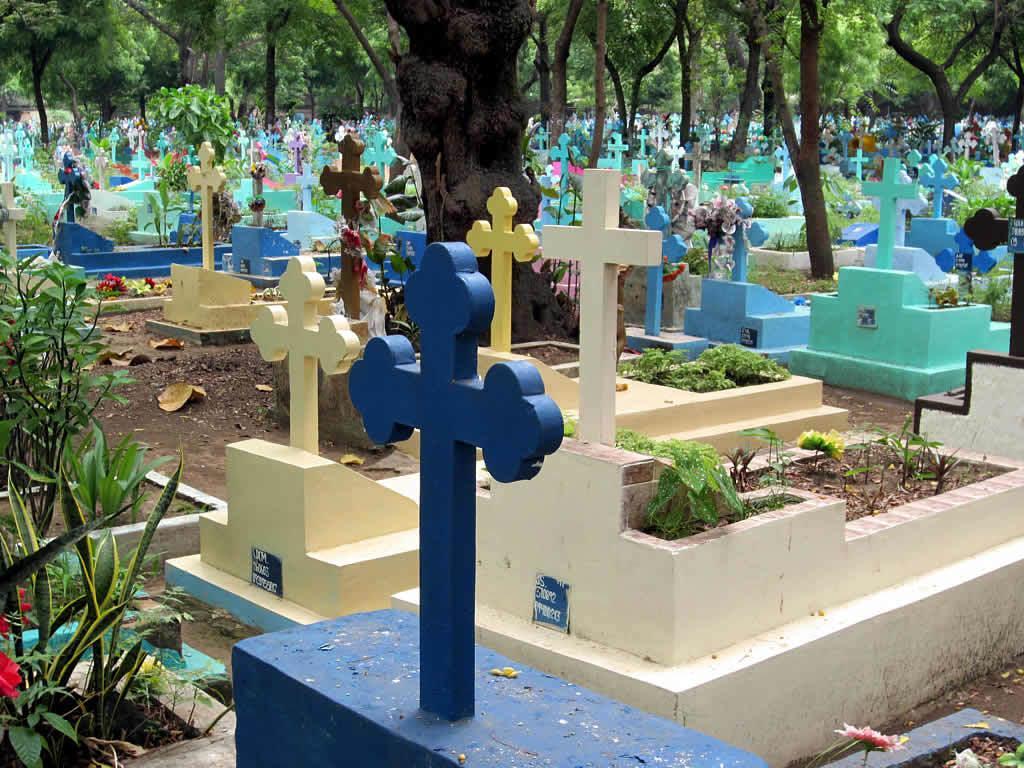In one or two sentences, can you explain what this image depicts? In this picture there are cemeteries and there are trees. At the bottom there is ground and there are dried leaves. 